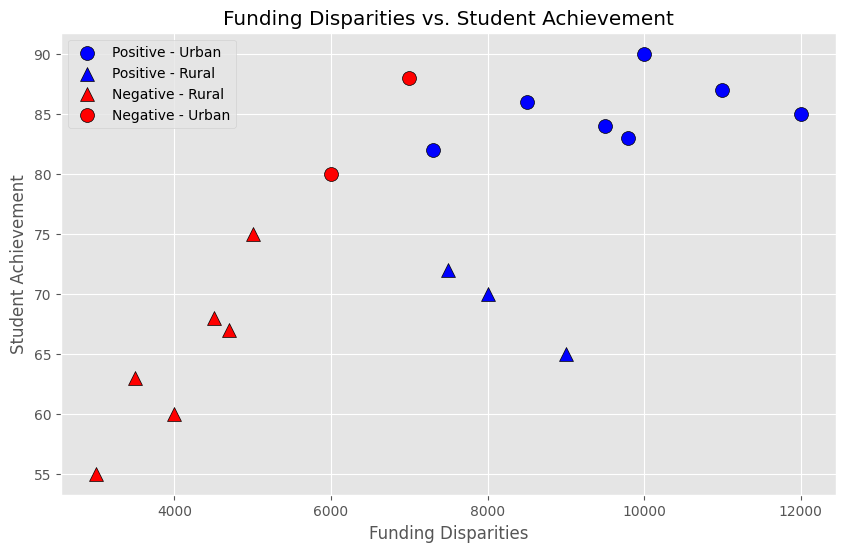What are the colors used to represent the positive and negative disparity types? The colors are blue and red. The blue represents the positive disparity type, and the red represents the negative disparity type. This can be seen from the plot's legend.
Answer: Blue for positive, red for negative Which group has higher student achievement on average, Urban or Rural? To determine the average student achievement for each group, we would sum the student achievement values for Urban and Rural groups separately and then divide by the number of data points in each group. Urban (90 + 85 + 80 + 88 + 87 + 84 + 86 + 83 + 82) / 9 = 83.89. Rural (75 + 70 + 65 + 60 + 68 + 55 + 72 + 63 + 67) / 9 = 66.11. Thus, Urban schools have a higher average student achievement.
Answer: Urban Which location has more data points in the plot, Urban or Rural? We count the number of scatter points associated with Urban (circles) and Rural (triangles) in the plot. Urban has 9 data points and Rural also has 9 data points. Thus, both have the same number of data points.
Answer: Both have the same What is the student achievement value where Urban schools with positive disparity type coincide? Observing the plot, there are multiple blue circles, which represent Urban schools with positive disparity. The student achievement values for these points are 90, 85, 87, 84, 86, 83, and 82. There is no single student achievement value where Urban schools with positive disparity type coincide.
Answer: No single value, multiple values Do Rural schools with negative disparity type show lower student achievements than Urban schools with negative disparity? On the plot, red triangles represent Rural schools with negative disparity, and red circles represent Urban schools with negative disparity. We compare the student achievement values: Rural negative (75, 60, 68, 55, 63, 67) versus Urban negative (80, 88). It appears that the Urban schools with negative disparity have higher student achievements than Rural schools with negative disparity.
Answer: Yes, lower Which type of schools (Urban or Rural) shows a wider range in funding disparities? To determine the range, we find the minimum and maximum funding disparities for both Urban and Rural locations. Urban funding disparities range from 6000 to 12000, a range of 6000. Rural funding disparities range from 3000 to 9000, a range of 6000. Both Urban and Rural show the same range in funding disparities.
Answer: Same range What is the maximum student achievement among Rural schools with positive disparity type? We identify the blue triangles on the plot, which represent Rural schools with positive disparity. The student achievement values for these points are 70, 65, and 72. Among these, the highest value is 72.
Answer: 72 